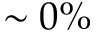<formula> <loc_0><loc_0><loc_500><loc_500>\sim 0 \%</formula> 